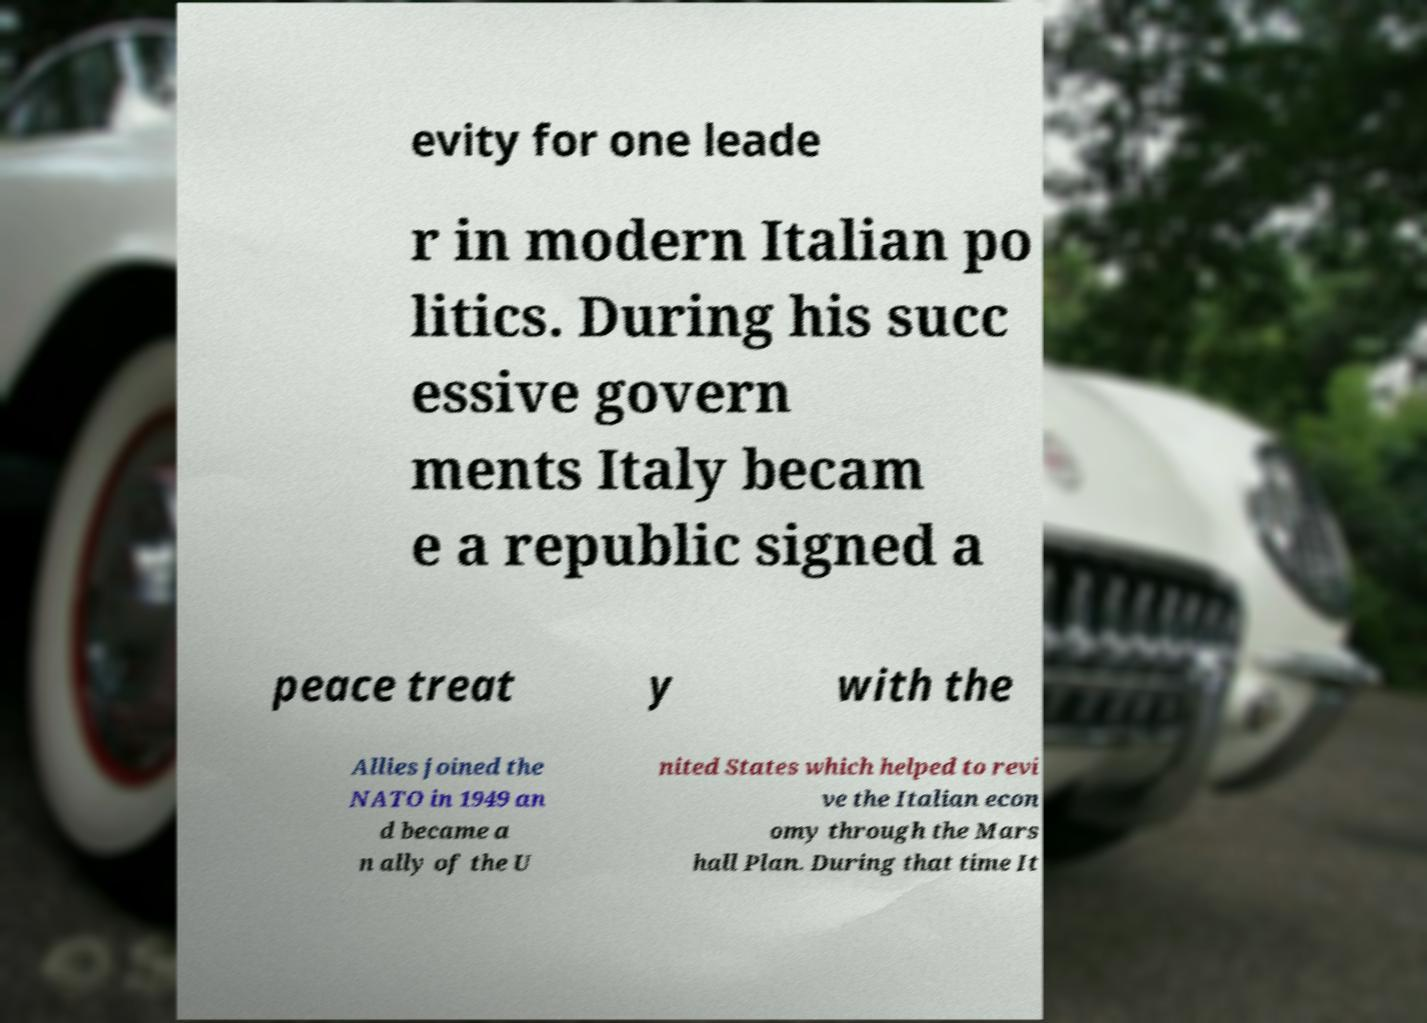There's text embedded in this image that I need extracted. Can you transcribe it verbatim? evity for one leade r in modern Italian po litics. During his succ essive govern ments Italy becam e a republic signed a peace treat y with the Allies joined the NATO in 1949 an d became a n ally of the U nited States which helped to revi ve the Italian econ omy through the Mars hall Plan. During that time It 